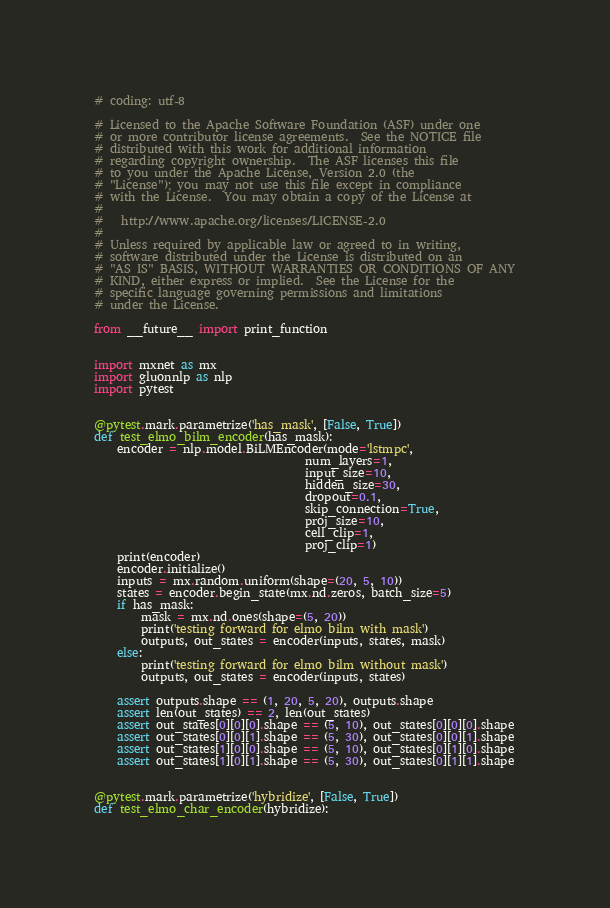<code> <loc_0><loc_0><loc_500><loc_500><_Python_># coding: utf-8

# Licensed to the Apache Software Foundation (ASF) under one
# or more contributor license agreements.  See the NOTICE file
# distributed with this work for additional information
# regarding copyright ownership.  The ASF licenses this file
# to you under the Apache License, Version 2.0 (the
# "License"); you may not use this file except in compliance
# with the License.  You may obtain a copy of the License at
#
#   http://www.apache.org/licenses/LICENSE-2.0
#
# Unless required by applicable law or agreed to in writing,
# software distributed under the License is distributed on an
# "AS IS" BASIS, WITHOUT WARRANTIES OR CONDITIONS OF ANY
# KIND, either express or implied.  See the License for the
# specific language governing permissions and limitations
# under the License.

from __future__ import print_function


import mxnet as mx
import gluonnlp as nlp
import pytest


@pytest.mark.parametrize('has_mask', [False, True])
def test_elmo_bilm_encoder(has_mask):
    encoder = nlp.model.BiLMEncoder(mode='lstmpc',
                                    num_layers=1,
                                    input_size=10,
                                    hidden_size=30,
                                    dropout=0.1,
                                    skip_connection=True,
                                    proj_size=10,
                                    cell_clip=1,
                                    proj_clip=1)
    print(encoder)
    encoder.initialize()
    inputs = mx.random.uniform(shape=(20, 5, 10))
    states = encoder.begin_state(mx.nd.zeros, batch_size=5)
    if has_mask:
        mask = mx.nd.ones(shape=(5, 20))
        print('testing forward for elmo bilm with mask')
        outputs, out_states = encoder(inputs, states, mask)
    else:
        print('testing forward for elmo bilm without mask')
        outputs, out_states = encoder(inputs, states)

    assert outputs.shape == (1, 20, 5, 20), outputs.shape
    assert len(out_states) == 2, len(out_states)
    assert out_states[0][0][0].shape == (5, 10), out_states[0][0][0].shape
    assert out_states[0][0][1].shape == (5, 30), out_states[0][0][1].shape
    assert out_states[1][0][0].shape == (5, 10), out_states[0][1][0].shape
    assert out_states[1][0][1].shape == (5, 30), out_states[0][1][1].shape


@pytest.mark.parametrize('hybridize', [False, True])
def test_elmo_char_encoder(hybridize):</code> 